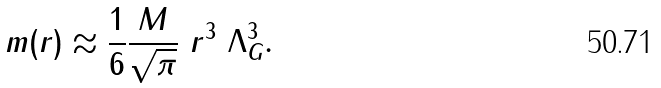<formula> <loc_0><loc_0><loc_500><loc_500>m ( r ) \approx \frac { 1 } { 6 } \frac { M } { \sqrt { \pi } } \ r ^ { 3 } \ \Lambda _ { G } ^ { 3 } .</formula> 